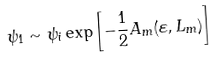Convert formula to latex. <formula><loc_0><loc_0><loc_500><loc_500>\psi _ { 1 } \sim \psi _ { i } \exp \left [ - \frac { 1 } { 2 } A _ { m } ( \varepsilon , L _ { m } ) \right ]</formula> 